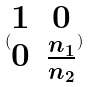Convert formula to latex. <formula><loc_0><loc_0><loc_500><loc_500>( \begin{matrix} 1 & 0 \\ 0 & \frac { n _ { 1 } } { n _ { 2 } } \end{matrix} )</formula> 